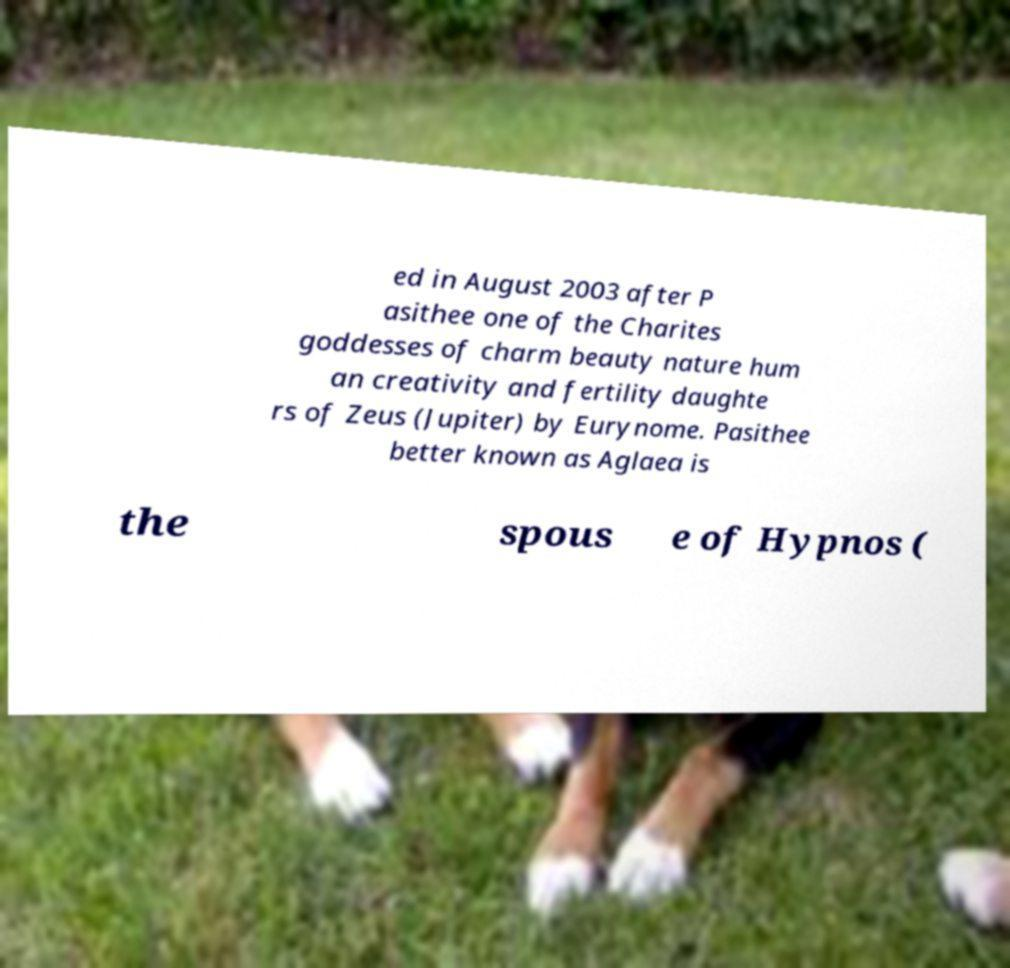I need the written content from this picture converted into text. Can you do that? ed in August 2003 after P asithee one of the Charites goddesses of charm beauty nature hum an creativity and fertility daughte rs of Zeus (Jupiter) by Eurynome. Pasithee better known as Aglaea is the spous e of Hypnos ( 